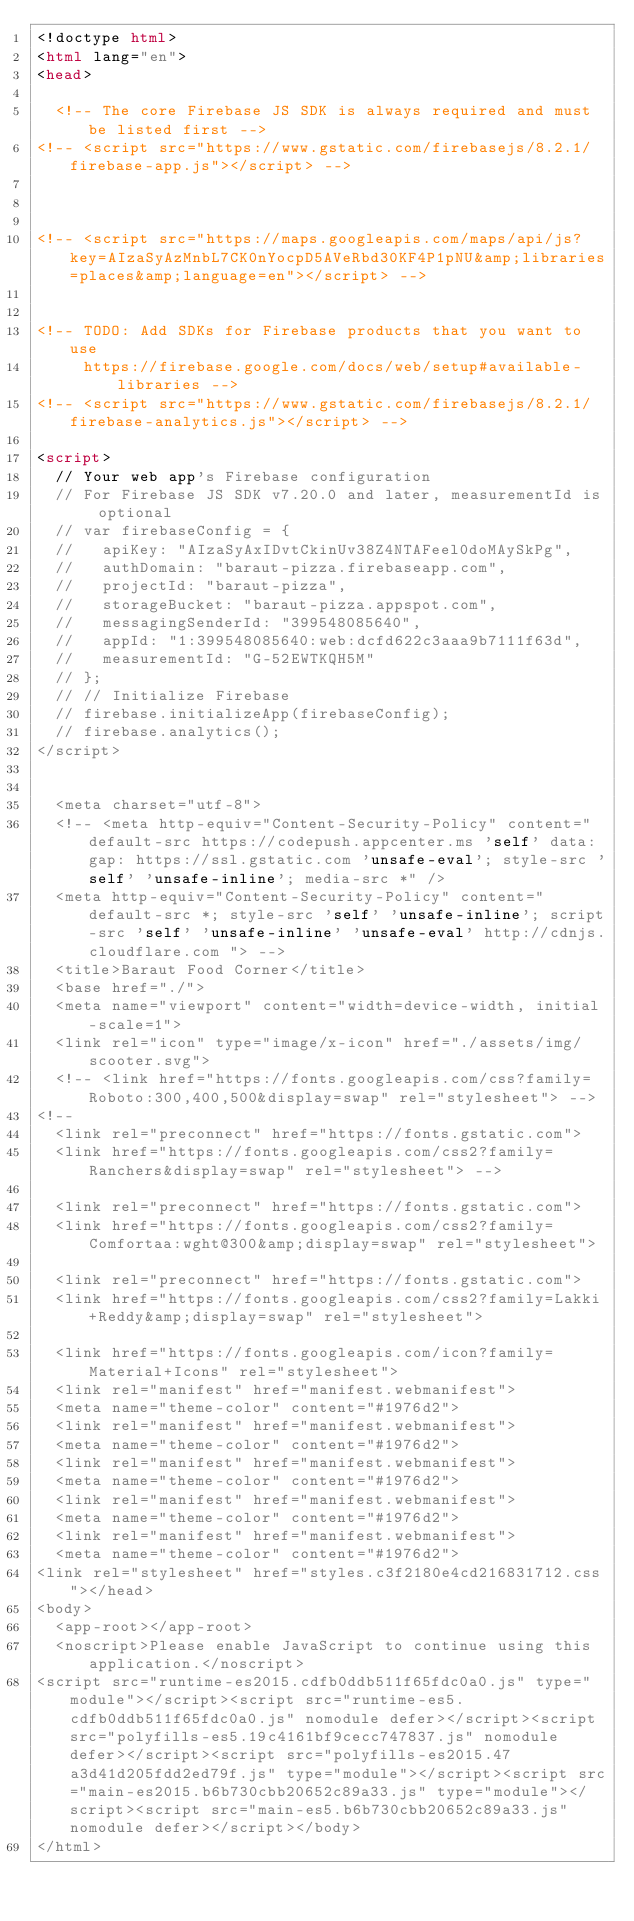<code> <loc_0><loc_0><loc_500><loc_500><_HTML_><!doctype html>
<html lang="en">
<head>

  <!-- The core Firebase JS SDK is always required and must be listed first -->
<!-- <script src="https://www.gstatic.com/firebasejs/8.2.1/firebase-app.js"></script> -->



<!-- <script src="https://maps.googleapis.com/maps/api/js?key=AIzaSyAzMnbL7CK0nYocpD5AVeRbd30KF4P1pNU&amp;libraries=places&amp;language=en"></script> -->


<!-- TODO: Add SDKs for Firebase products that you want to use
     https://firebase.google.com/docs/web/setup#available-libraries -->
<!-- <script src="https://www.gstatic.com/firebasejs/8.2.1/firebase-analytics.js"></script> -->

<script>
  // Your web app's Firebase configuration
  // For Firebase JS SDK v7.20.0 and later, measurementId is optional
  // var firebaseConfig = {
  //   apiKey: "AIzaSyAxIDvtCkinUv38Z4NTAFeel0doMAySkPg",
  //   authDomain: "baraut-pizza.firebaseapp.com",
  //   projectId: "baraut-pizza",
  //   storageBucket: "baraut-pizza.appspot.com",
  //   messagingSenderId: "399548085640",
  //   appId: "1:399548085640:web:dcfd622c3aaa9b7111f63d",
  //   measurementId: "G-52EWTKQH5M"
  // };
  // // Initialize Firebase
  // firebase.initializeApp(firebaseConfig);
  // firebase.analytics();
</script>


  <meta charset="utf-8">
  <!-- <meta http-equiv="Content-Security-Policy" content="default-src https://codepush.appcenter.ms 'self' data: gap: https://ssl.gstatic.com 'unsafe-eval'; style-src 'self' 'unsafe-inline'; media-src *" />
  <meta http-equiv="Content-Security-Policy" content="default-src *; style-src 'self' 'unsafe-inline'; script-src 'self' 'unsafe-inline' 'unsafe-eval' http://cdnjs.cloudflare.com "> -->
  <title>Baraut Food Corner</title>
  <base href="./">
  <meta name="viewport" content="width=device-width, initial-scale=1">
  <link rel="icon" type="image/x-icon" href="./assets/img/scooter.svg">
  <!-- <link href="https://fonts.googleapis.com/css?family=Roboto:300,400,500&display=swap" rel="stylesheet"> -->
<!--
  <link rel="preconnect" href="https://fonts.gstatic.com">
  <link href="https://fonts.googleapis.com/css2?family=Ranchers&display=swap" rel="stylesheet"> -->

  <link rel="preconnect" href="https://fonts.gstatic.com">
  <link href="https://fonts.googleapis.com/css2?family=Comfortaa:wght@300&amp;display=swap" rel="stylesheet">

  <link rel="preconnect" href="https://fonts.gstatic.com">
  <link href="https://fonts.googleapis.com/css2?family=Lakki+Reddy&amp;display=swap" rel="stylesheet">

  <link href="https://fonts.googleapis.com/icon?family=Material+Icons" rel="stylesheet">
  <link rel="manifest" href="manifest.webmanifest">
  <meta name="theme-color" content="#1976d2">
  <link rel="manifest" href="manifest.webmanifest">
  <meta name="theme-color" content="#1976d2">
  <link rel="manifest" href="manifest.webmanifest">
  <meta name="theme-color" content="#1976d2">
  <link rel="manifest" href="manifest.webmanifest">
  <meta name="theme-color" content="#1976d2">
  <link rel="manifest" href="manifest.webmanifest">
  <meta name="theme-color" content="#1976d2">
<link rel="stylesheet" href="styles.c3f2180e4cd216831712.css"></head>
<body>
  <app-root></app-root>
  <noscript>Please enable JavaScript to continue using this application.</noscript>
<script src="runtime-es2015.cdfb0ddb511f65fdc0a0.js" type="module"></script><script src="runtime-es5.cdfb0ddb511f65fdc0a0.js" nomodule defer></script><script src="polyfills-es5.19c4161bf9cecc747837.js" nomodule defer></script><script src="polyfills-es2015.47a3d41d205fdd2ed79f.js" type="module"></script><script src="main-es2015.b6b730cbb20652c89a33.js" type="module"></script><script src="main-es5.b6b730cbb20652c89a33.js" nomodule defer></script></body>
</html>
</code> 